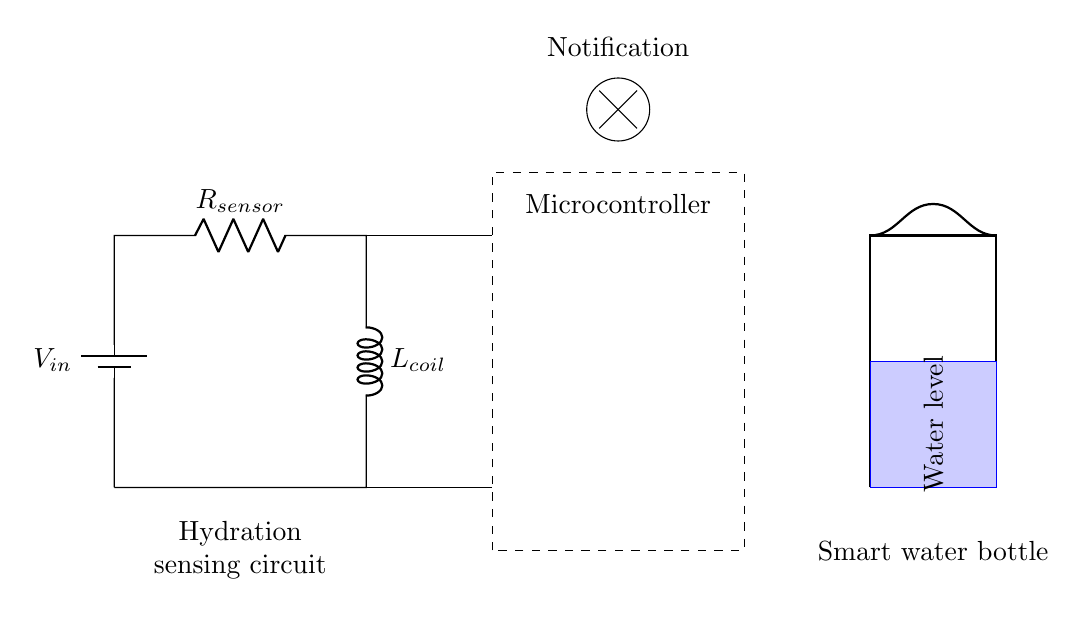What is the battery's voltage in the circuit? The battery is labeled as V_in in the diagram, which indicates it provides the input voltage for the circuit. However, the specific value is not given in the diagram. It will depend on the design specifications.
Answer: V_in What component is used for sensing hydration? The circuit includes a resistor labeled R_sensor, which likely serves the purpose of detecting changes related to the hydration level based on its resistance.
Answer: R_sensor What does the microcontroller do in this circuit? The microcontroller connects to both the sensor and the inductor, indicating that it likely processes signals from the hydration sensor and controls notifications related to water intake reminders.
Answer: Processes signals Which component creates a magnetic field in the circuit? The inductor is labeled L_coil, which generates a magnetic field when current flows through it, playing a crucial role in the operation of the circuit in relation to timing or controlling signals.
Answer: L_coil How does the circuit notify the user? The circuit shows a notification symbol suggesting that the microcontroller drives a notification mechanism, potentially sending alerts to the user when it's time to drink water, indicated by its connection to the rest of the circuit.
Answer: Notification What is the relationship between the resistor and inductor in this circuit? The resistor and inductor are connected in series, which means the total impedance affects the circuit's behavior. This configuration helps in timing delays, filtering signals, or integrating with the microcontroller for hydration reminders.
Answer: Series connection 